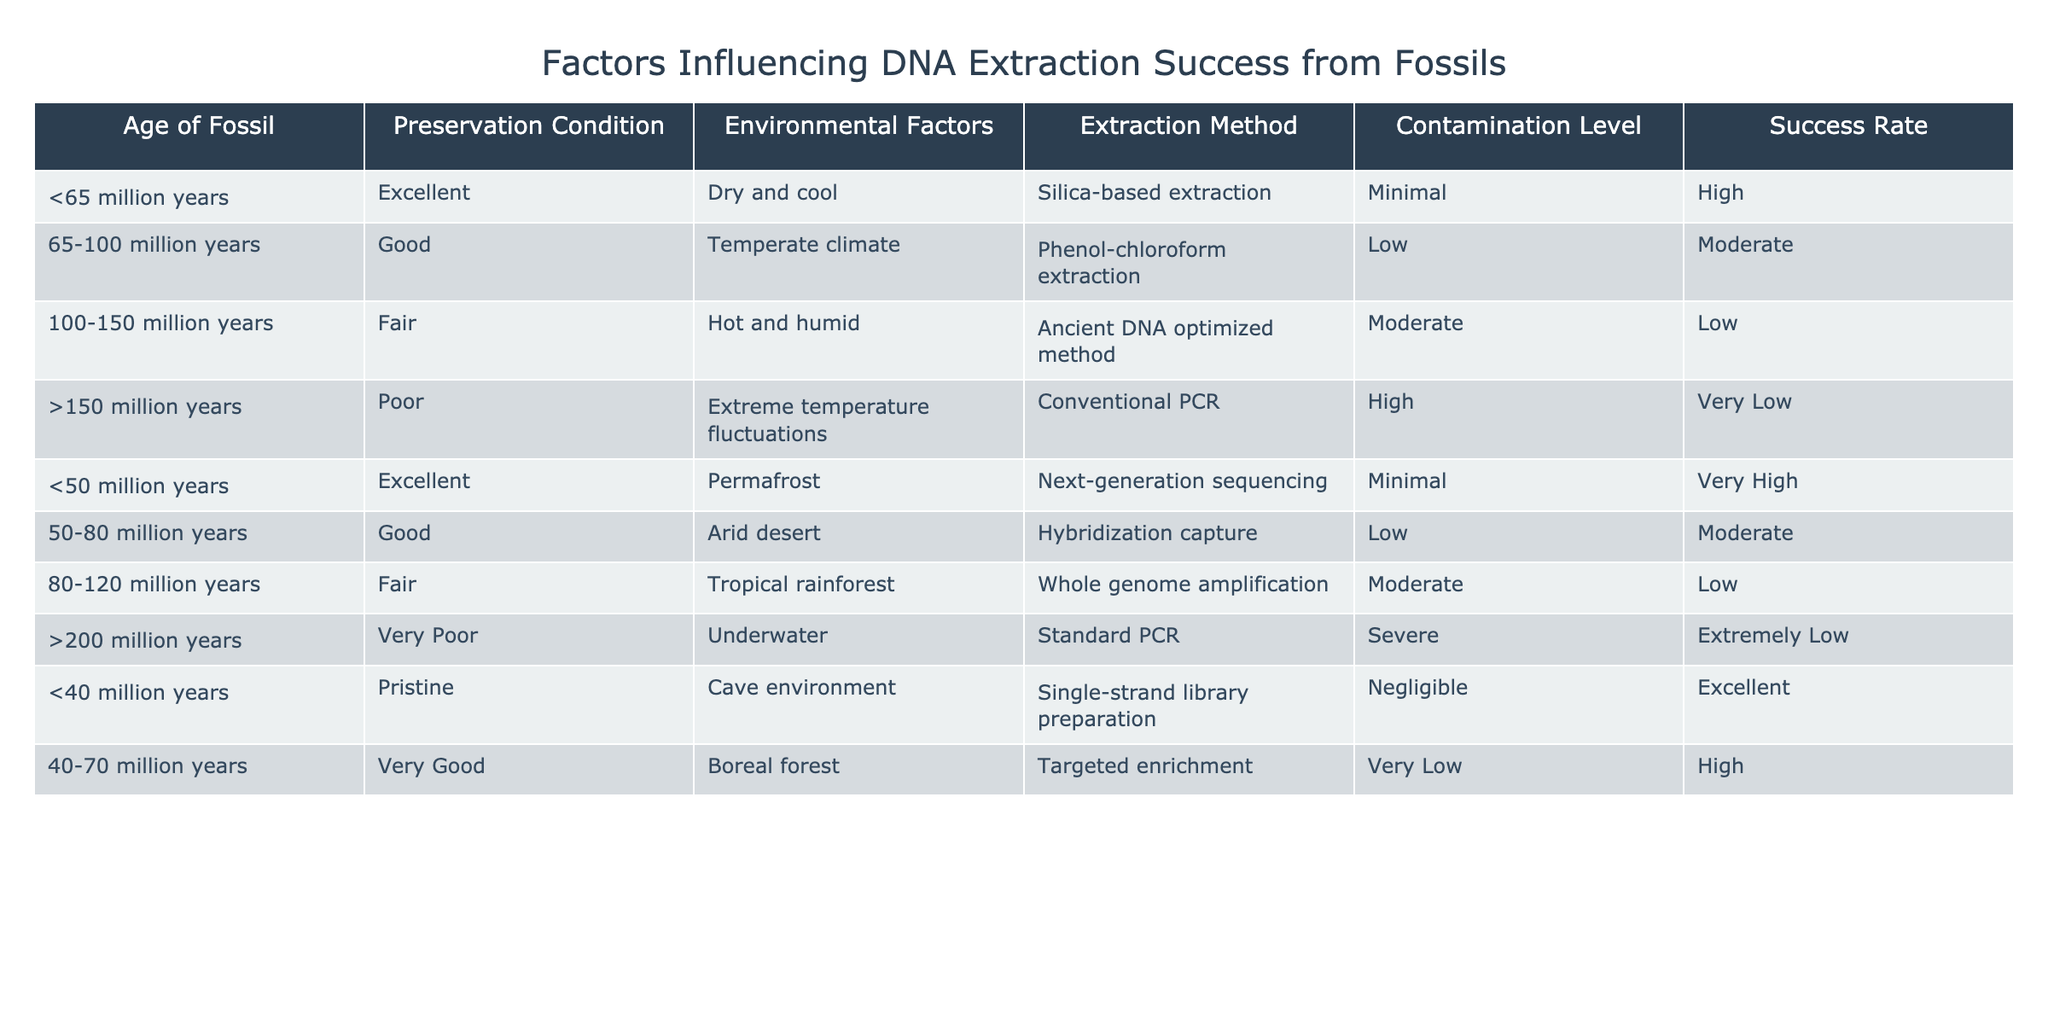What is the success rate for the extraction method used with fossils aged >200 million years? The table indicates that for fossils older than 200 million years, the success rate for the standard PCR extraction method is categorized as extremely low.
Answer: Extremely Low Which fossil age range has the highest success rate? Referring to the table, the age range <50 million years with the next-generation sequencing method has the highest success rate, classified as very high.
Answer: Very High Is it true that all fossils older than 150 million years have a poor extraction success rate? By analyzing the table, it shows that fossils aged >150 million years have a poor preservation condition and the success rates categorized are very low and extremely low, confirming the statement is true.
Answer: True What is the average success rate of extraction methods for fossils between 65 and 100 million years old? The success rate for the given age range includes moderate success for phenol-chloroform extraction and low success for the ancient DNA optimized method. Combining these two success ratings yields moderate (1) and low (0), giving an average of (1 + 0) / 2 = 0.5; the average in this context would be categorized as low overall.
Answer: Low Which extraction method shows minimal contamination levels for fossils aged less than 50 million years? Upon examining the table, it indicates that the extraction method for fossils aged under 50 million years, which is next-generation sequencing, demonstrates minimal contamination levels.
Answer: Next-generation sequencing For fossils aged between 40 and 70 million years, what is the preservation condition, and what is the success rate? According to the table, fossils in the age range of 40 to 70 million years have a very good preservation condition and a high success rate, classified respectively.
Answer: Very Good and High 